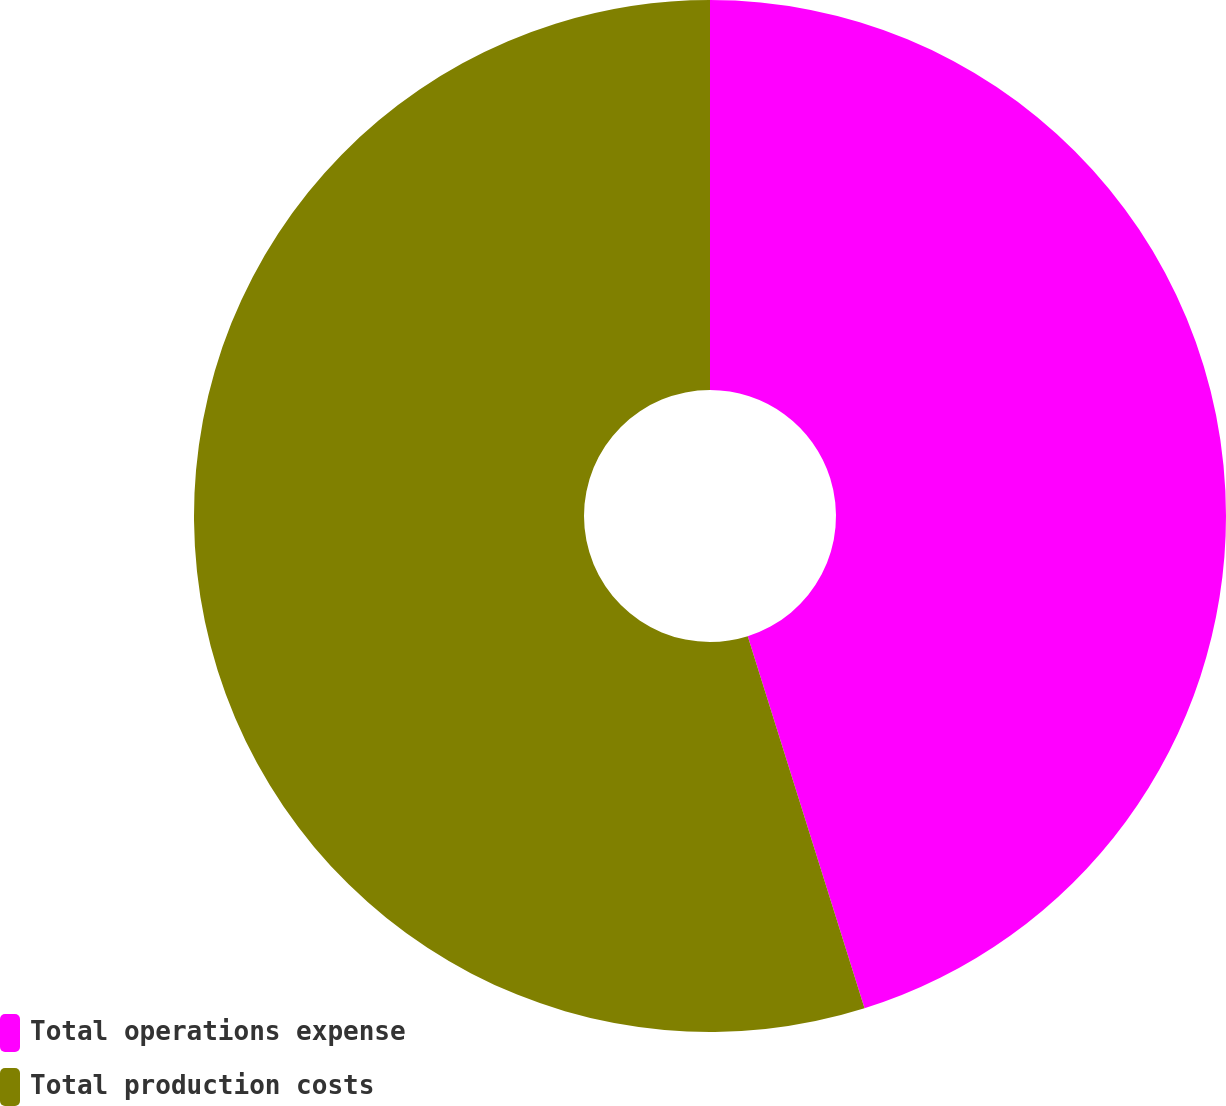Convert chart to OTSL. <chart><loc_0><loc_0><loc_500><loc_500><pie_chart><fcel>Total operations expense<fcel>Total production costs<nl><fcel>45.16%<fcel>54.84%<nl></chart> 